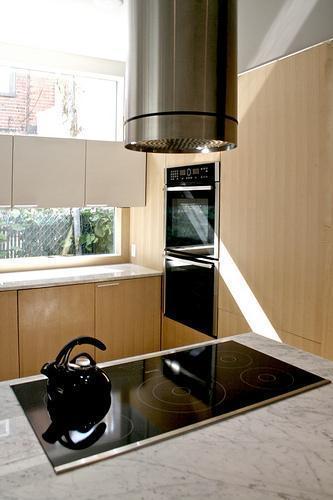How many burners does the range have?
Give a very brief answer. 5. How many ovens can be seen?
Give a very brief answer. 2. 